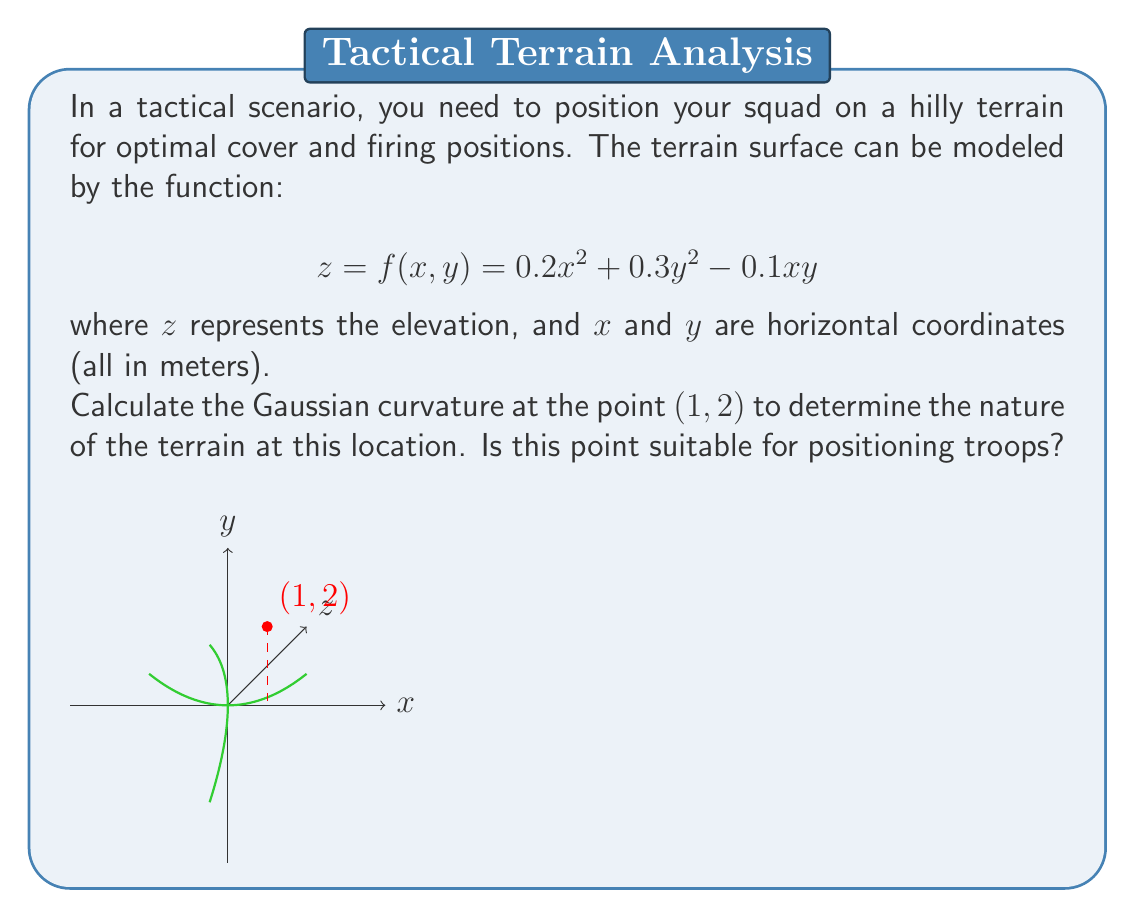Can you answer this question? To calculate the Gaussian curvature, we need to follow these steps:

1) The Gaussian curvature K is given by:

   $$K = \frac{f_{xx}f_{yy} - f_{xy}^2}{(1 + f_x^2 + f_y^2)^2}$$

   where subscripts denote partial derivatives.

2) Calculate the required partial derivatives:
   $$f_x = 0.4x - 0.1y$$
   $$f_y = 0.6y - 0.1x$$
   $$f_{xx} = 0.4$$
   $$f_{yy} = 0.6$$
   $$f_{xy} = -0.1$$

3) Evaluate these at the point (1, 2):
   $$f_x = 0.4(1) - 0.1(2) = 0.2$$
   $$f_y = 0.6(2) - 0.1(1) = 1.1$$
   $$f_{xx} = 0.4$$
   $$f_{yy} = 0.6$$
   $$f_{xy} = -0.1$$

4) Substitute into the curvature formula:

   $$K = \frac{(0.4)(0.6) - (-0.1)^2}{(1 + 0.2^2 + 1.1^2)^2}$$

5) Simplify:
   $$K = \frac{0.24 - 0.01}{(1 + 0.04 + 1.21)^2} = \frac{0.23}{2.25^2} \approx 0.0455$$

The positive Gaussian curvature indicates that this point is elliptic, meaning it's either a local maximum or minimum. Given the shape of the function, it's likely a local minimum.

For tactical positioning, a local minimum could provide good cover, as it's surrounded by higher ground. However, it may limit visibility and firing positions. The relatively low curvature suggests a gentle slope, which could be advantageous for troop movement.
Answer: $K \approx 0.0455$ m^(-2); suitable for cover but may limit visibility. 